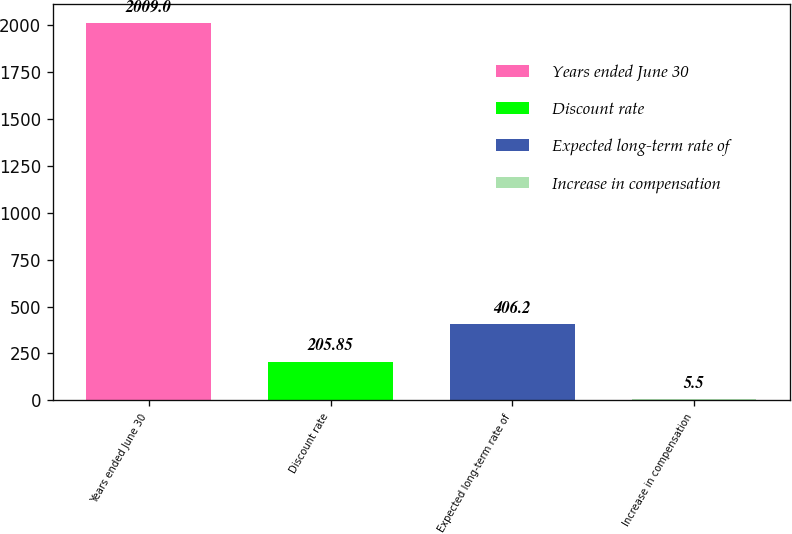<chart> <loc_0><loc_0><loc_500><loc_500><bar_chart><fcel>Years ended June 30<fcel>Discount rate<fcel>Expected long-term rate of<fcel>Increase in compensation<nl><fcel>2009<fcel>205.85<fcel>406.2<fcel>5.5<nl></chart> 